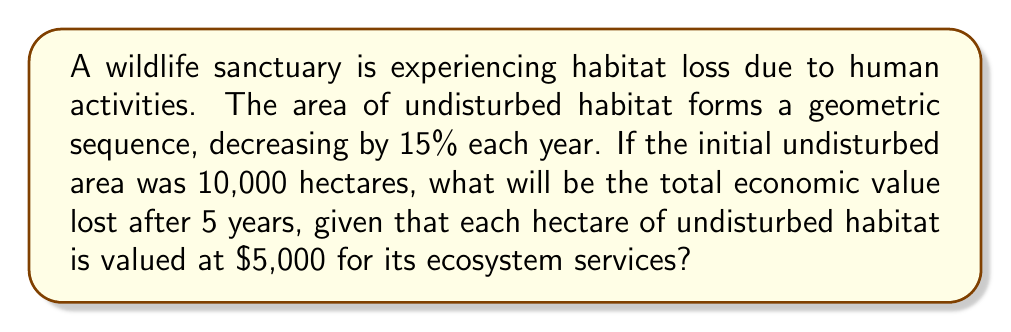Teach me how to tackle this problem. Let's approach this step-by-step:

1) First, we need to determine the geometric sequence for the undisturbed area:
   - Initial area: $a_1 = 10,000$ hectares
   - Common ratio: $r = 1 - 0.15 = 0.85$ (85% of the previous year's area remains)

2) The sequence of undisturbed areas over 5 years is:
   $$a_n = a_1 \cdot r^{n-1}$$
   where $n$ is the year number.

3) Calculate the areas for each year:
   Year 1: $a_1 = 10,000$ hectares
   Year 2: $a_2 = 10,000 \cdot 0.85^1 = 8,500$ hectares
   Year 3: $a_3 = 10,000 \cdot 0.85^2 = 7,225$ hectares
   Year 4: $a_4 = 10,000 \cdot 0.85^3 \approx 6,141.25$ hectares
   Year 5: $a_5 = 10,000 \cdot 0.85^4 \approx 5,220.06$ hectares

4) Total area lost over 5 years:
   $$\text{Area lost} = 10,000 - 5,220.06 = 4,779.94 \text{ hectares}$$

5) Economic value lost:
   $$\text{Value lost} = 4,779.94 \cdot \$5,000 = \$23,899,700$$

Therefore, the total economic value lost after 5 years is approximately $23,899,700.
Answer: $23,899,700 